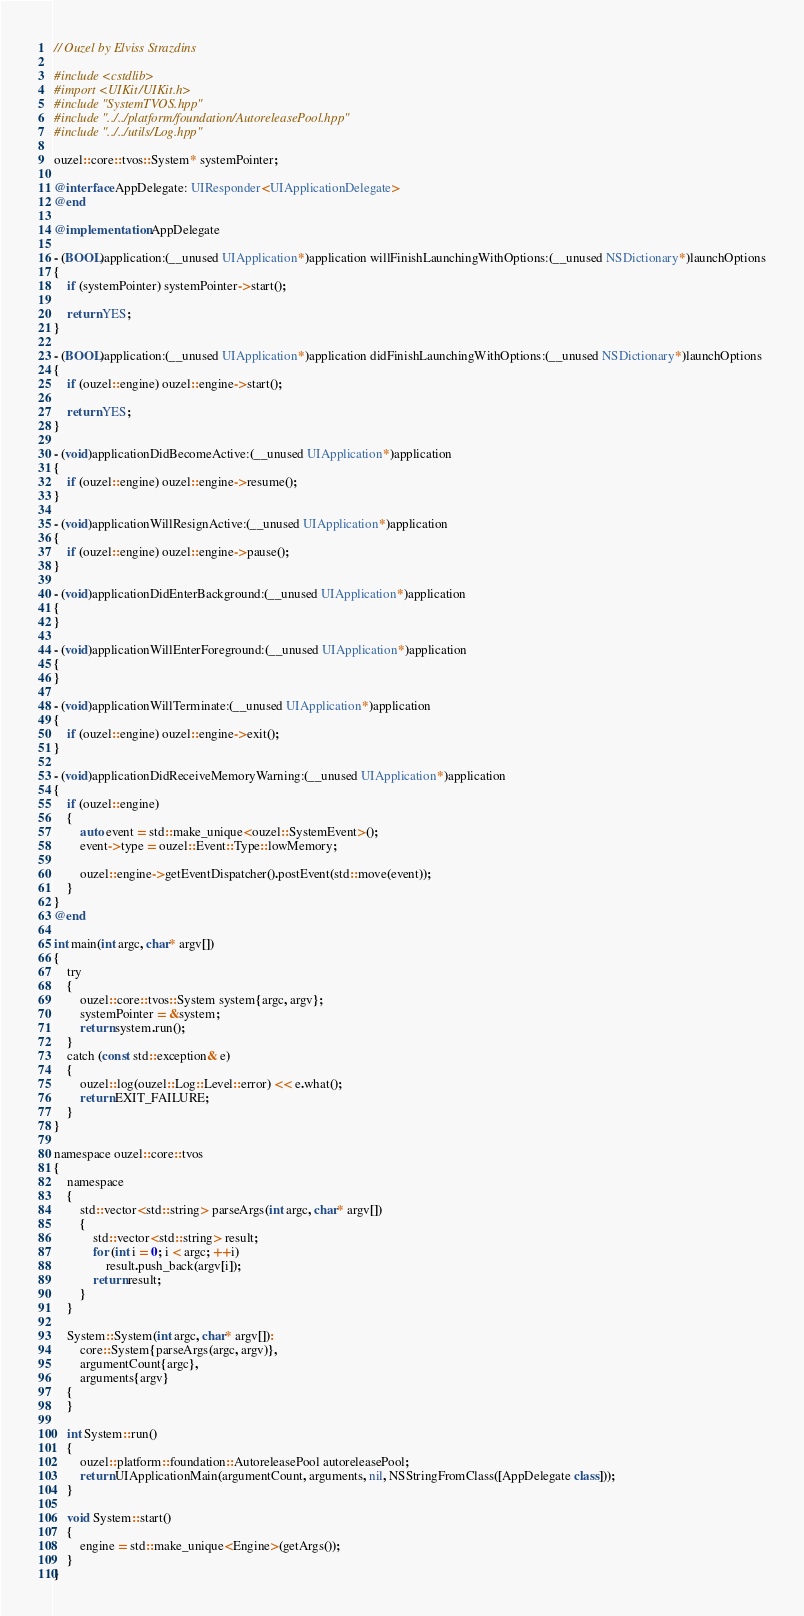Convert code to text. <code><loc_0><loc_0><loc_500><loc_500><_ObjectiveC_>// Ouzel by Elviss Strazdins

#include <cstdlib>
#import <UIKit/UIKit.h>
#include "SystemTVOS.hpp"
#include "../../platform/foundation/AutoreleasePool.hpp"
#include "../../utils/Log.hpp"

ouzel::core::tvos::System* systemPointer;

@interface AppDelegate: UIResponder<UIApplicationDelegate>
@end

@implementation AppDelegate

- (BOOL)application:(__unused UIApplication*)application willFinishLaunchingWithOptions:(__unused NSDictionary*)launchOptions
{
    if (systemPointer) systemPointer->start();

    return YES;
}

- (BOOL)application:(__unused UIApplication*)application didFinishLaunchingWithOptions:(__unused NSDictionary*)launchOptions
{
    if (ouzel::engine) ouzel::engine->start();

    return YES;
}

- (void)applicationDidBecomeActive:(__unused UIApplication*)application
{
    if (ouzel::engine) ouzel::engine->resume();
}

- (void)applicationWillResignActive:(__unused UIApplication*)application
{
    if (ouzel::engine) ouzel::engine->pause();
}

- (void)applicationDidEnterBackground:(__unused UIApplication*)application
{
}

- (void)applicationWillEnterForeground:(__unused UIApplication*)application
{
}

- (void)applicationWillTerminate:(__unused UIApplication*)application
{
    if (ouzel::engine) ouzel::engine->exit();
}

- (void)applicationDidReceiveMemoryWarning:(__unused UIApplication*)application
{
    if (ouzel::engine)
    {
        auto event = std::make_unique<ouzel::SystemEvent>();
        event->type = ouzel::Event::Type::lowMemory;

        ouzel::engine->getEventDispatcher().postEvent(std::move(event));
    }
}
@end

int main(int argc, char* argv[])
{
    try
    {
        ouzel::core::tvos::System system{argc, argv};
        systemPointer = &system;
        return system.run();
    }
    catch (const std::exception& e)
    {
        ouzel::log(ouzel::Log::Level::error) << e.what();
        return EXIT_FAILURE;
    }
}

namespace ouzel::core::tvos
{
    namespace
    {
        std::vector<std::string> parseArgs(int argc, char* argv[])
        {
            std::vector<std::string> result;
            for (int i = 0; i < argc; ++i)
                result.push_back(argv[i]);
            return result;
        }
    }

    System::System(int argc, char* argv[]):
        core::System{parseArgs(argc, argv)},
        argumentCount{argc},
        arguments{argv}
    {
    }

    int System::run()
    {
        ouzel::platform::foundation::AutoreleasePool autoreleasePool;
        return UIApplicationMain(argumentCount, arguments, nil, NSStringFromClass([AppDelegate class]));
    }

    void System::start()
    {
        engine = std::make_unique<Engine>(getArgs());
    }
}
</code> 